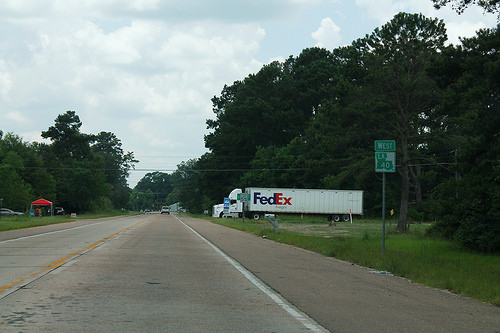<image>
Can you confirm if the truck is on the road? Yes. Looking at the image, I can see the truck is positioned on top of the road, with the road providing support. 